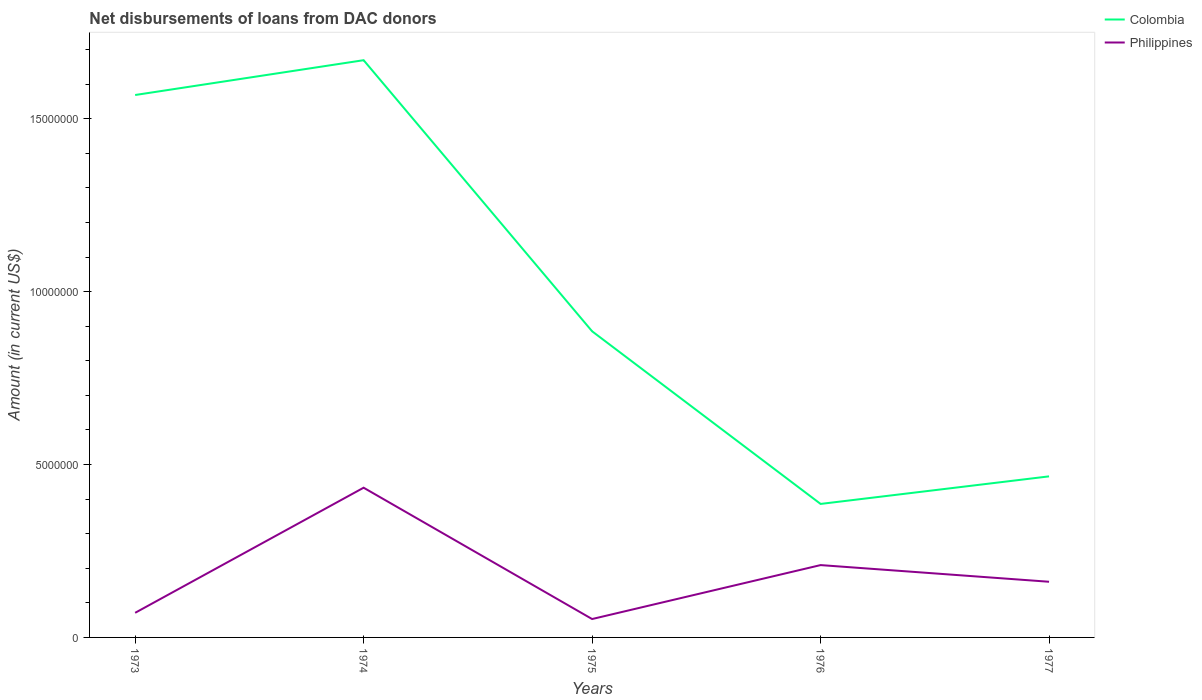How many different coloured lines are there?
Your answer should be compact. 2. Is the number of lines equal to the number of legend labels?
Offer a terse response. Yes. Across all years, what is the maximum amount of loans disbursed in Colombia?
Provide a short and direct response. 3.86e+06. In which year was the amount of loans disbursed in Philippines maximum?
Give a very brief answer. 1975. What is the total amount of loans disbursed in Colombia in the graph?
Your response must be concise. -7.97e+05. What is the difference between the highest and the second highest amount of loans disbursed in Philippines?
Give a very brief answer. 3.80e+06. What is the difference between the highest and the lowest amount of loans disbursed in Philippines?
Provide a succinct answer. 2. Is the amount of loans disbursed in Philippines strictly greater than the amount of loans disbursed in Colombia over the years?
Keep it short and to the point. Yes. Does the graph contain any zero values?
Your response must be concise. No. Does the graph contain grids?
Your response must be concise. No. Where does the legend appear in the graph?
Offer a terse response. Top right. What is the title of the graph?
Provide a succinct answer. Net disbursements of loans from DAC donors. Does "Timor-Leste" appear as one of the legend labels in the graph?
Your answer should be very brief. No. What is the Amount (in current US$) in Colombia in 1973?
Offer a terse response. 1.57e+07. What is the Amount (in current US$) of Philippines in 1973?
Make the answer very short. 7.12e+05. What is the Amount (in current US$) of Colombia in 1974?
Provide a succinct answer. 1.67e+07. What is the Amount (in current US$) of Philippines in 1974?
Give a very brief answer. 4.33e+06. What is the Amount (in current US$) in Colombia in 1975?
Your answer should be very brief. 8.85e+06. What is the Amount (in current US$) in Philippines in 1975?
Keep it short and to the point. 5.32e+05. What is the Amount (in current US$) of Colombia in 1976?
Provide a succinct answer. 3.86e+06. What is the Amount (in current US$) of Philippines in 1976?
Provide a succinct answer. 2.09e+06. What is the Amount (in current US$) of Colombia in 1977?
Your answer should be very brief. 4.66e+06. What is the Amount (in current US$) in Philippines in 1977?
Provide a short and direct response. 1.61e+06. Across all years, what is the maximum Amount (in current US$) of Colombia?
Give a very brief answer. 1.67e+07. Across all years, what is the maximum Amount (in current US$) of Philippines?
Make the answer very short. 4.33e+06. Across all years, what is the minimum Amount (in current US$) in Colombia?
Your response must be concise. 3.86e+06. Across all years, what is the minimum Amount (in current US$) in Philippines?
Offer a very short reply. 5.32e+05. What is the total Amount (in current US$) in Colombia in the graph?
Provide a succinct answer. 4.98e+07. What is the total Amount (in current US$) of Philippines in the graph?
Make the answer very short. 9.28e+06. What is the difference between the Amount (in current US$) in Colombia in 1973 and that in 1974?
Your answer should be compact. -1.01e+06. What is the difference between the Amount (in current US$) of Philippines in 1973 and that in 1974?
Ensure brevity in your answer.  -3.62e+06. What is the difference between the Amount (in current US$) in Colombia in 1973 and that in 1975?
Your answer should be compact. 6.83e+06. What is the difference between the Amount (in current US$) in Colombia in 1973 and that in 1976?
Your answer should be compact. 1.18e+07. What is the difference between the Amount (in current US$) of Philippines in 1973 and that in 1976?
Offer a terse response. -1.38e+06. What is the difference between the Amount (in current US$) of Colombia in 1973 and that in 1977?
Offer a terse response. 1.10e+07. What is the difference between the Amount (in current US$) in Philippines in 1973 and that in 1977?
Keep it short and to the point. -8.98e+05. What is the difference between the Amount (in current US$) of Colombia in 1974 and that in 1975?
Provide a succinct answer. 7.84e+06. What is the difference between the Amount (in current US$) in Philippines in 1974 and that in 1975?
Your answer should be compact. 3.80e+06. What is the difference between the Amount (in current US$) of Colombia in 1974 and that in 1976?
Offer a very short reply. 1.28e+07. What is the difference between the Amount (in current US$) of Philippines in 1974 and that in 1976?
Your response must be concise. 2.24e+06. What is the difference between the Amount (in current US$) in Colombia in 1974 and that in 1977?
Make the answer very short. 1.20e+07. What is the difference between the Amount (in current US$) in Philippines in 1974 and that in 1977?
Your response must be concise. 2.72e+06. What is the difference between the Amount (in current US$) in Colombia in 1975 and that in 1976?
Ensure brevity in your answer.  4.99e+06. What is the difference between the Amount (in current US$) of Philippines in 1975 and that in 1976?
Your response must be concise. -1.56e+06. What is the difference between the Amount (in current US$) of Colombia in 1975 and that in 1977?
Provide a succinct answer. 4.20e+06. What is the difference between the Amount (in current US$) in Philippines in 1975 and that in 1977?
Offer a terse response. -1.08e+06. What is the difference between the Amount (in current US$) in Colombia in 1976 and that in 1977?
Make the answer very short. -7.97e+05. What is the difference between the Amount (in current US$) of Philippines in 1976 and that in 1977?
Give a very brief answer. 4.82e+05. What is the difference between the Amount (in current US$) in Colombia in 1973 and the Amount (in current US$) in Philippines in 1974?
Your answer should be compact. 1.14e+07. What is the difference between the Amount (in current US$) in Colombia in 1973 and the Amount (in current US$) in Philippines in 1975?
Give a very brief answer. 1.52e+07. What is the difference between the Amount (in current US$) of Colombia in 1973 and the Amount (in current US$) of Philippines in 1976?
Make the answer very short. 1.36e+07. What is the difference between the Amount (in current US$) in Colombia in 1973 and the Amount (in current US$) in Philippines in 1977?
Offer a very short reply. 1.41e+07. What is the difference between the Amount (in current US$) of Colombia in 1974 and the Amount (in current US$) of Philippines in 1975?
Offer a terse response. 1.62e+07. What is the difference between the Amount (in current US$) in Colombia in 1974 and the Amount (in current US$) in Philippines in 1976?
Give a very brief answer. 1.46e+07. What is the difference between the Amount (in current US$) of Colombia in 1974 and the Amount (in current US$) of Philippines in 1977?
Keep it short and to the point. 1.51e+07. What is the difference between the Amount (in current US$) in Colombia in 1975 and the Amount (in current US$) in Philippines in 1976?
Make the answer very short. 6.76e+06. What is the difference between the Amount (in current US$) of Colombia in 1975 and the Amount (in current US$) of Philippines in 1977?
Your answer should be compact. 7.24e+06. What is the difference between the Amount (in current US$) in Colombia in 1976 and the Amount (in current US$) in Philippines in 1977?
Ensure brevity in your answer.  2.25e+06. What is the average Amount (in current US$) in Colombia per year?
Keep it short and to the point. 9.95e+06. What is the average Amount (in current US$) of Philippines per year?
Give a very brief answer. 1.86e+06. In the year 1973, what is the difference between the Amount (in current US$) of Colombia and Amount (in current US$) of Philippines?
Your answer should be very brief. 1.50e+07. In the year 1974, what is the difference between the Amount (in current US$) of Colombia and Amount (in current US$) of Philippines?
Your answer should be very brief. 1.24e+07. In the year 1975, what is the difference between the Amount (in current US$) of Colombia and Amount (in current US$) of Philippines?
Offer a terse response. 8.32e+06. In the year 1976, what is the difference between the Amount (in current US$) in Colombia and Amount (in current US$) in Philippines?
Keep it short and to the point. 1.77e+06. In the year 1977, what is the difference between the Amount (in current US$) in Colombia and Amount (in current US$) in Philippines?
Keep it short and to the point. 3.05e+06. What is the ratio of the Amount (in current US$) in Colombia in 1973 to that in 1974?
Provide a short and direct response. 0.94. What is the ratio of the Amount (in current US$) of Philippines in 1973 to that in 1974?
Give a very brief answer. 0.16. What is the ratio of the Amount (in current US$) of Colombia in 1973 to that in 1975?
Your answer should be compact. 1.77. What is the ratio of the Amount (in current US$) of Philippines in 1973 to that in 1975?
Provide a succinct answer. 1.34. What is the ratio of the Amount (in current US$) in Colombia in 1973 to that in 1976?
Keep it short and to the point. 4.06. What is the ratio of the Amount (in current US$) in Philippines in 1973 to that in 1976?
Your response must be concise. 0.34. What is the ratio of the Amount (in current US$) of Colombia in 1973 to that in 1977?
Make the answer very short. 3.37. What is the ratio of the Amount (in current US$) of Philippines in 1973 to that in 1977?
Offer a very short reply. 0.44. What is the ratio of the Amount (in current US$) in Colombia in 1974 to that in 1975?
Your answer should be compact. 1.89. What is the ratio of the Amount (in current US$) of Philippines in 1974 to that in 1975?
Keep it short and to the point. 8.14. What is the ratio of the Amount (in current US$) in Colombia in 1974 to that in 1976?
Make the answer very short. 4.32. What is the ratio of the Amount (in current US$) in Philippines in 1974 to that in 1976?
Ensure brevity in your answer.  2.07. What is the ratio of the Amount (in current US$) in Colombia in 1974 to that in 1977?
Keep it short and to the point. 3.58. What is the ratio of the Amount (in current US$) of Philippines in 1974 to that in 1977?
Make the answer very short. 2.69. What is the ratio of the Amount (in current US$) in Colombia in 1975 to that in 1976?
Your response must be concise. 2.29. What is the ratio of the Amount (in current US$) of Philippines in 1975 to that in 1976?
Ensure brevity in your answer.  0.25. What is the ratio of the Amount (in current US$) in Colombia in 1975 to that in 1977?
Make the answer very short. 1.9. What is the ratio of the Amount (in current US$) in Philippines in 1975 to that in 1977?
Give a very brief answer. 0.33. What is the ratio of the Amount (in current US$) in Colombia in 1976 to that in 1977?
Your answer should be compact. 0.83. What is the ratio of the Amount (in current US$) in Philippines in 1976 to that in 1977?
Ensure brevity in your answer.  1.3. What is the difference between the highest and the second highest Amount (in current US$) in Colombia?
Offer a terse response. 1.01e+06. What is the difference between the highest and the second highest Amount (in current US$) in Philippines?
Give a very brief answer. 2.24e+06. What is the difference between the highest and the lowest Amount (in current US$) of Colombia?
Provide a succinct answer. 1.28e+07. What is the difference between the highest and the lowest Amount (in current US$) of Philippines?
Keep it short and to the point. 3.80e+06. 